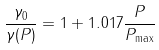<formula> <loc_0><loc_0><loc_500><loc_500>\frac { \gamma _ { 0 } } { \gamma ( P ) } = 1 + 1 . 0 1 7 \frac { P } { P _ { \max } }</formula> 